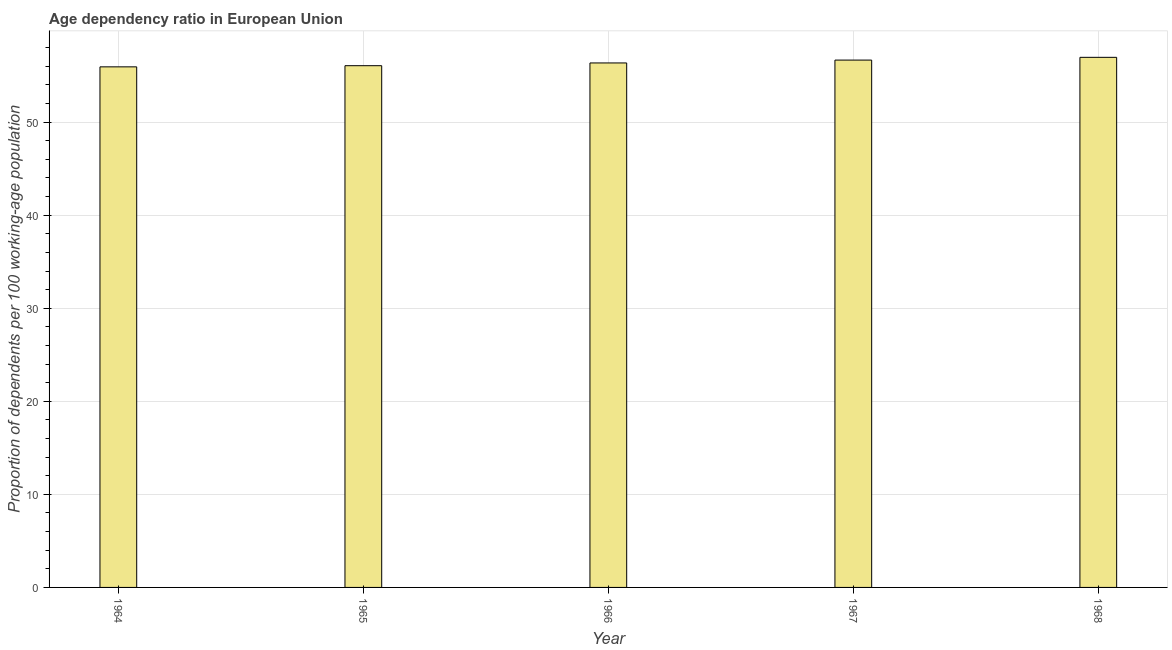What is the title of the graph?
Ensure brevity in your answer.  Age dependency ratio in European Union. What is the label or title of the Y-axis?
Give a very brief answer. Proportion of dependents per 100 working-age population. What is the age dependency ratio in 1966?
Provide a short and direct response. 56.36. Across all years, what is the maximum age dependency ratio?
Offer a very short reply. 56.96. Across all years, what is the minimum age dependency ratio?
Provide a succinct answer. 55.94. In which year was the age dependency ratio maximum?
Your answer should be compact. 1968. In which year was the age dependency ratio minimum?
Your answer should be compact. 1964. What is the sum of the age dependency ratio?
Offer a terse response. 281.98. What is the difference between the age dependency ratio in 1964 and 1968?
Your response must be concise. -1.02. What is the average age dependency ratio per year?
Keep it short and to the point. 56.4. What is the median age dependency ratio?
Your response must be concise. 56.36. What is the ratio of the age dependency ratio in 1964 to that in 1965?
Ensure brevity in your answer.  1. Is the age dependency ratio in 1966 less than that in 1967?
Ensure brevity in your answer.  Yes. Is the difference between the age dependency ratio in 1965 and 1967 greater than the difference between any two years?
Offer a very short reply. No. What is the difference between the highest and the second highest age dependency ratio?
Give a very brief answer. 0.3. Is the sum of the age dependency ratio in 1965 and 1968 greater than the maximum age dependency ratio across all years?
Your answer should be compact. Yes. In how many years, is the age dependency ratio greater than the average age dependency ratio taken over all years?
Offer a terse response. 2. Are all the bars in the graph horizontal?
Offer a terse response. No. How many years are there in the graph?
Keep it short and to the point. 5. Are the values on the major ticks of Y-axis written in scientific E-notation?
Make the answer very short. No. What is the Proportion of dependents per 100 working-age population in 1964?
Keep it short and to the point. 55.94. What is the Proportion of dependents per 100 working-age population of 1965?
Give a very brief answer. 56.06. What is the Proportion of dependents per 100 working-age population in 1966?
Ensure brevity in your answer.  56.36. What is the Proportion of dependents per 100 working-age population of 1967?
Offer a terse response. 56.66. What is the Proportion of dependents per 100 working-age population of 1968?
Offer a very short reply. 56.96. What is the difference between the Proportion of dependents per 100 working-age population in 1964 and 1965?
Keep it short and to the point. -0.12. What is the difference between the Proportion of dependents per 100 working-age population in 1964 and 1966?
Offer a very short reply. -0.42. What is the difference between the Proportion of dependents per 100 working-age population in 1964 and 1967?
Provide a succinct answer. -0.73. What is the difference between the Proportion of dependents per 100 working-age population in 1964 and 1968?
Provide a short and direct response. -1.02. What is the difference between the Proportion of dependents per 100 working-age population in 1965 and 1966?
Provide a succinct answer. -0.3. What is the difference between the Proportion of dependents per 100 working-age population in 1965 and 1967?
Your answer should be very brief. -0.6. What is the difference between the Proportion of dependents per 100 working-age population in 1965 and 1968?
Keep it short and to the point. -0.9. What is the difference between the Proportion of dependents per 100 working-age population in 1966 and 1967?
Provide a short and direct response. -0.31. What is the difference between the Proportion of dependents per 100 working-age population in 1966 and 1968?
Ensure brevity in your answer.  -0.6. What is the difference between the Proportion of dependents per 100 working-age population in 1967 and 1968?
Keep it short and to the point. -0.3. What is the ratio of the Proportion of dependents per 100 working-age population in 1964 to that in 1967?
Offer a terse response. 0.99. What is the ratio of the Proportion of dependents per 100 working-age population in 1965 to that in 1967?
Your answer should be compact. 0.99. What is the ratio of the Proportion of dependents per 100 working-age population in 1965 to that in 1968?
Ensure brevity in your answer.  0.98. What is the ratio of the Proportion of dependents per 100 working-age population in 1966 to that in 1967?
Offer a terse response. 0.99. 